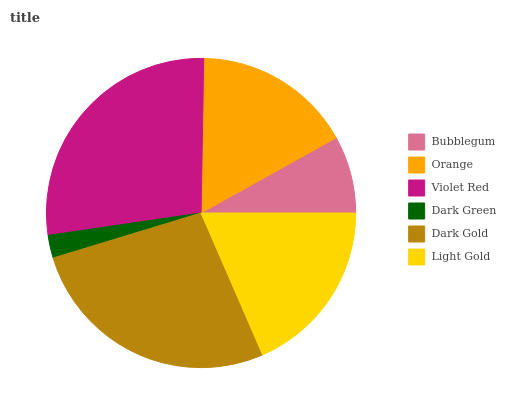Is Dark Green the minimum?
Answer yes or no. Yes. Is Violet Red the maximum?
Answer yes or no. Yes. Is Orange the minimum?
Answer yes or no. No. Is Orange the maximum?
Answer yes or no. No. Is Orange greater than Bubblegum?
Answer yes or no. Yes. Is Bubblegum less than Orange?
Answer yes or no. Yes. Is Bubblegum greater than Orange?
Answer yes or no. No. Is Orange less than Bubblegum?
Answer yes or no. No. Is Light Gold the high median?
Answer yes or no. Yes. Is Orange the low median?
Answer yes or no. Yes. Is Dark Green the high median?
Answer yes or no. No. Is Light Gold the low median?
Answer yes or no. No. 